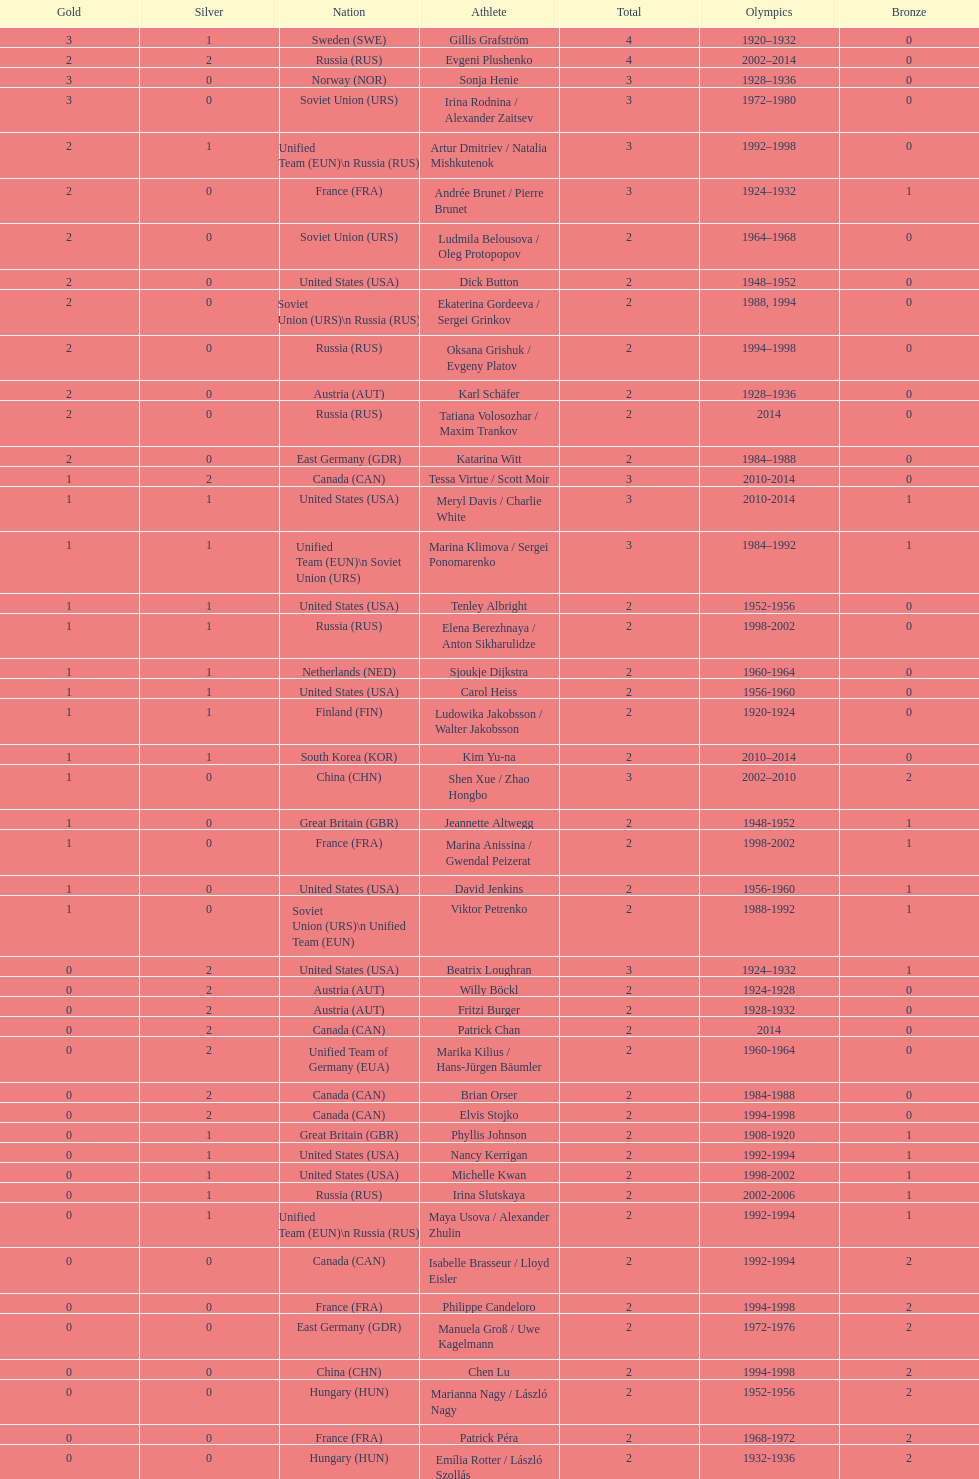Which country initially achieved three olympic gold medals in figure skating? Sweden. 